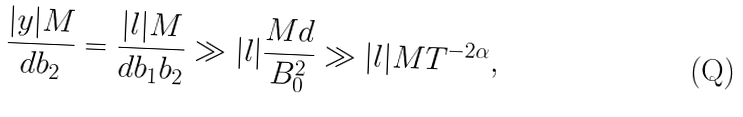Convert formula to latex. <formula><loc_0><loc_0><loc_500><loc_500>\frac { | y | M } { d b _ { 2 } } = \frac { | l | M } { d b _ { 1 } b _ { 2 } } \gg | l | \frac { M d } { B _ { 0 } ^ { 2 } } \gg | l | M T ^ { - 2 \alpha } ,</formula> 